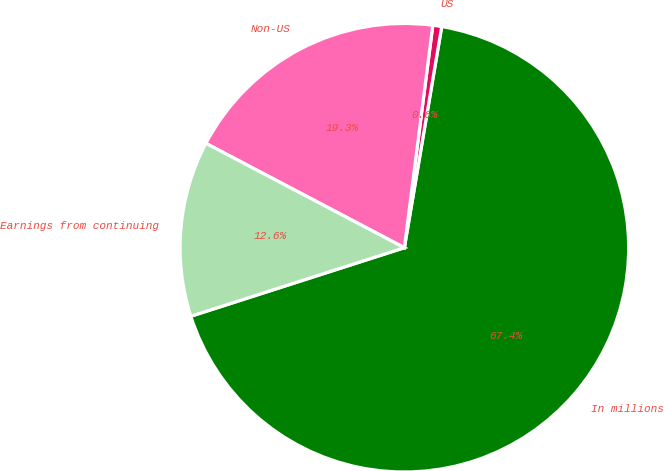Convert chart to OTSL. <chart><loc_0><loc_0><loc_500><loc_500><pie_chart><fcel>In millions<fcel>US<fcel>Non-US<fcel>Earnings from continuing<nl><fcel>67.4%<fcel>0.64%<fcel>19.32%<fcel>12.65%<nl></chart> 